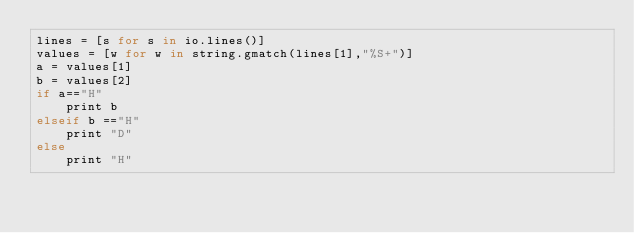Convert code to text. <code><loc_0><loc_0><loc_500><loc_500><_MoonScript_>lines = [s for s in io.lines()]
values = [w for w in string.gmatch(lines[1],"%S+")]
a = values[1]
b = values[2]
if a=="H"
	print b
elseif b =="H"
	print "D"
else
	print "H"
</code> 